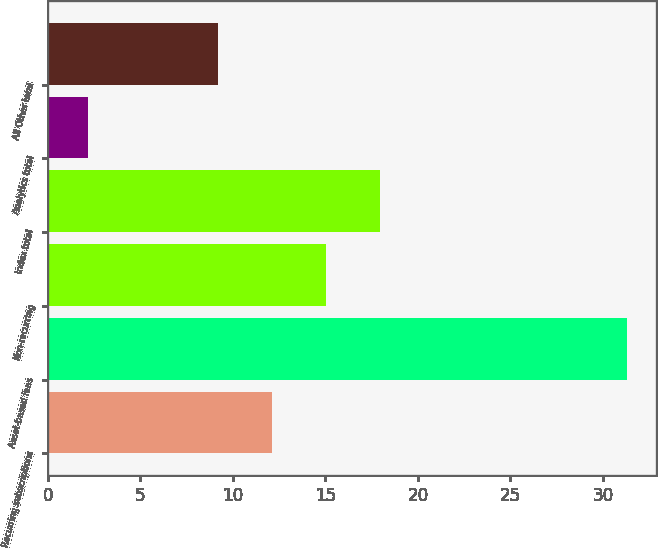Convert chart to OTSL. <chart><loc_0><loc_0><loc_500><loc_500><bar_chart><fcel>Recurring subscriptions<fcel>Asset-based fees<fcel>Non-recurring<fcel>Index total<fcel>Analytics total<fcel>All Other total<nl><fcel>12.11<fcel>31.3<fcel>15.02<fcel>17.93<fcel>2.2<fcel>9.2<nl></chart> 